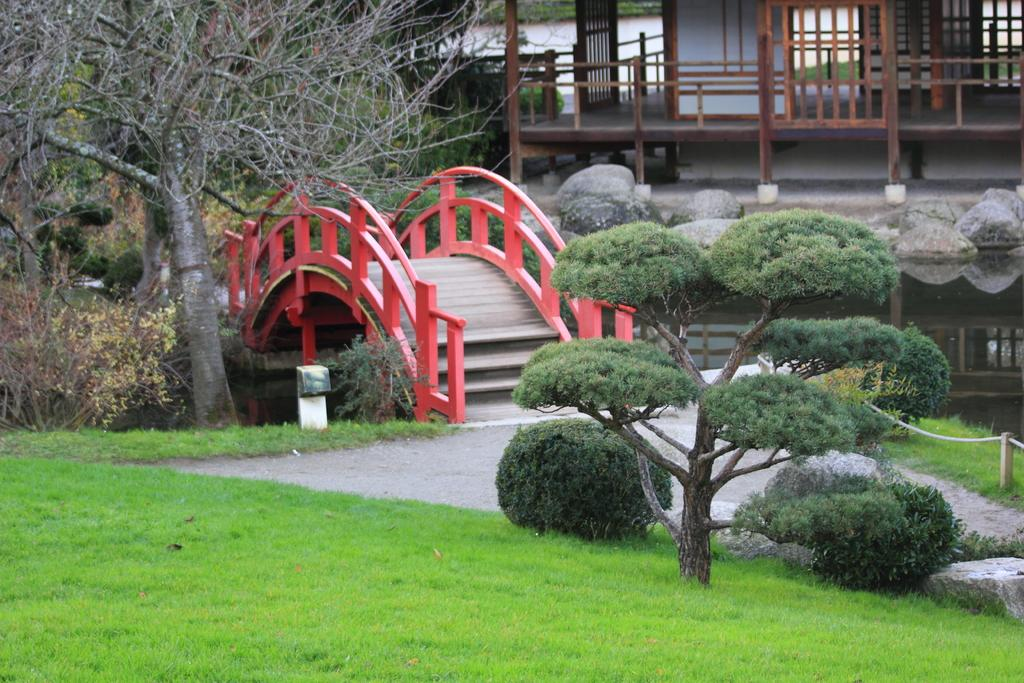What is the main structure in the center of the image? There is a bridge in the center of the image. What type of vegetation can be seen at the bottom of the image? There is grass on the surface at the bottom of the image. What other natural elements are present in the image? There are plants, trees, and rocks in the image. Are there any man-made structures visible in the image? Yes, there are buildings in the image. What type of toothbrush is the queen using in the image? There is no toothbrush or queen present in the image. What is the queen eating for breakfast in the image? There is no queen or breakfast present in the image. 